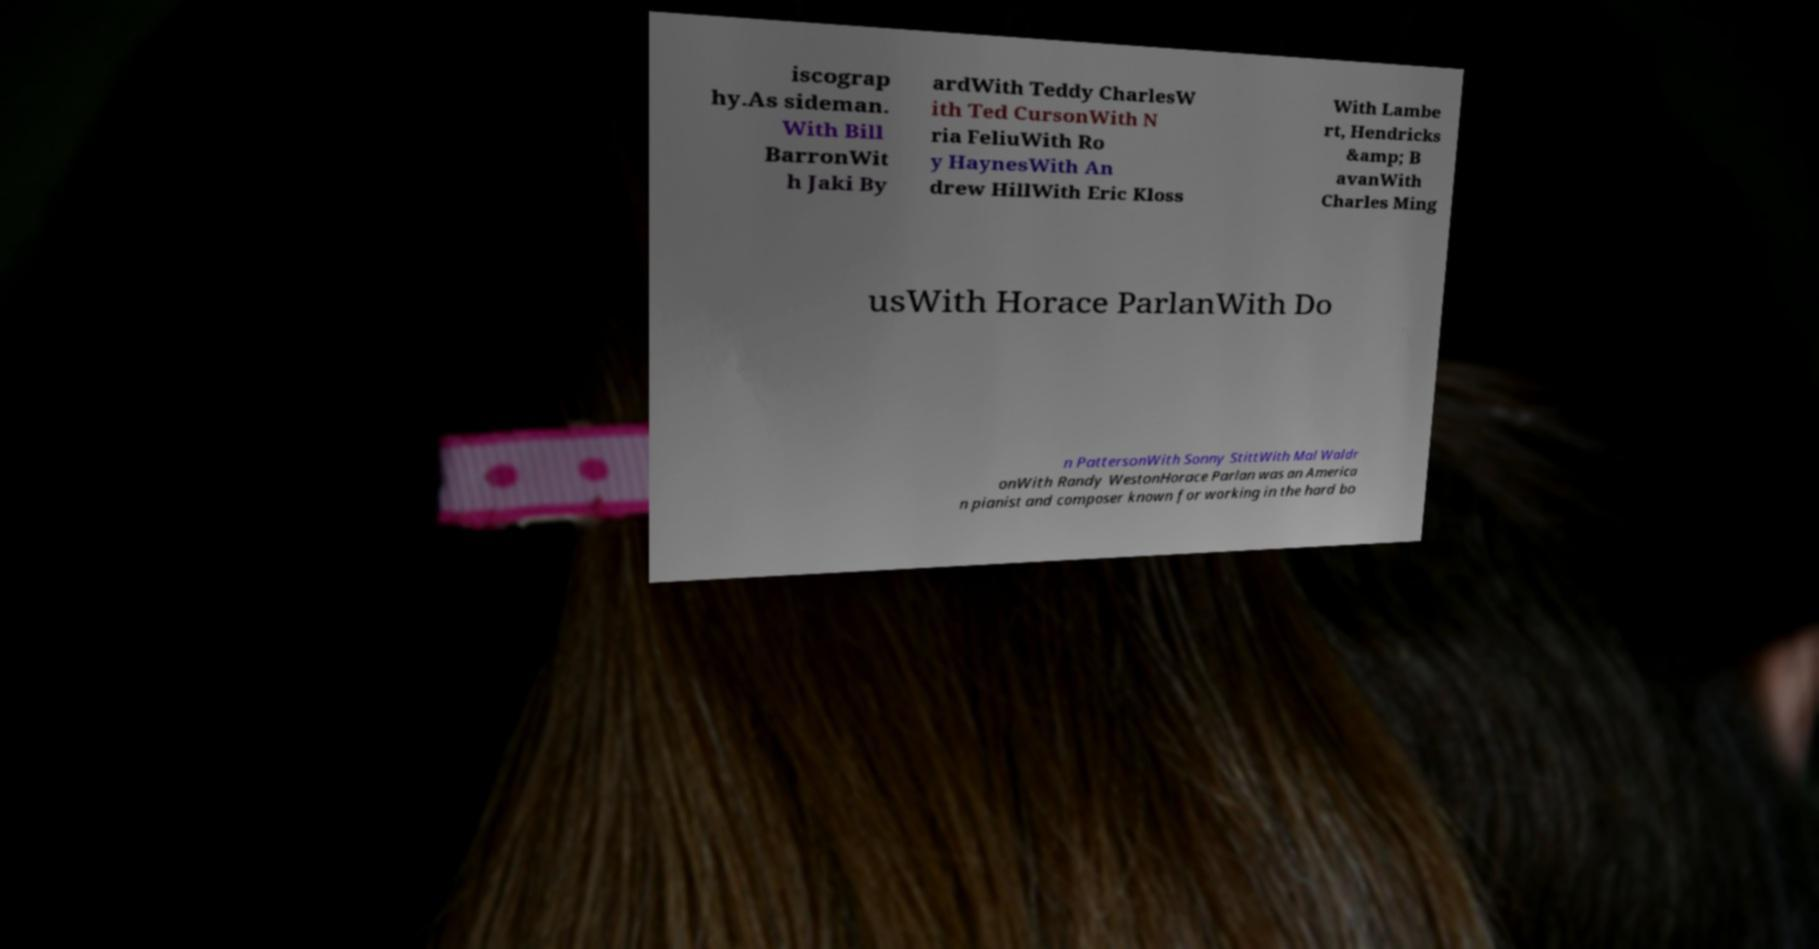For documentation purposes, I need the text within this image transcribed. Could you provide that? iscograp hy.As sideman. With Bill BarronWit h Jaki By ardWith Teddy CharlesW ith Ted CursonWith N ria FeliuWith Ro y HaynesWith An drew HillWith Eric Kloss With Lambe rt, Hendricks &amp; B avanWith Charles Ming usWith Horace ParlanWith Do n PattersonWith Sonny StittWith Mal Waldr onWith Randy WestonHorace Parlan was an America n pianist and composer known for working in the hard bo 